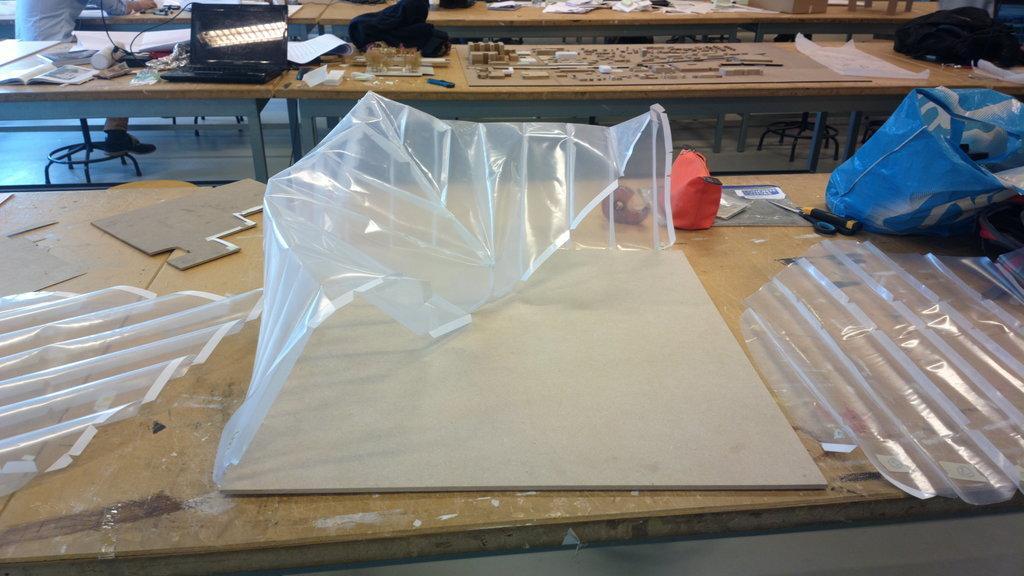Describe this image in one or two sentences. In this image I can see number of tables and on these tables I can see few bags, a laptop and many other stuffs. In the front I can see few plastic stuffs. 